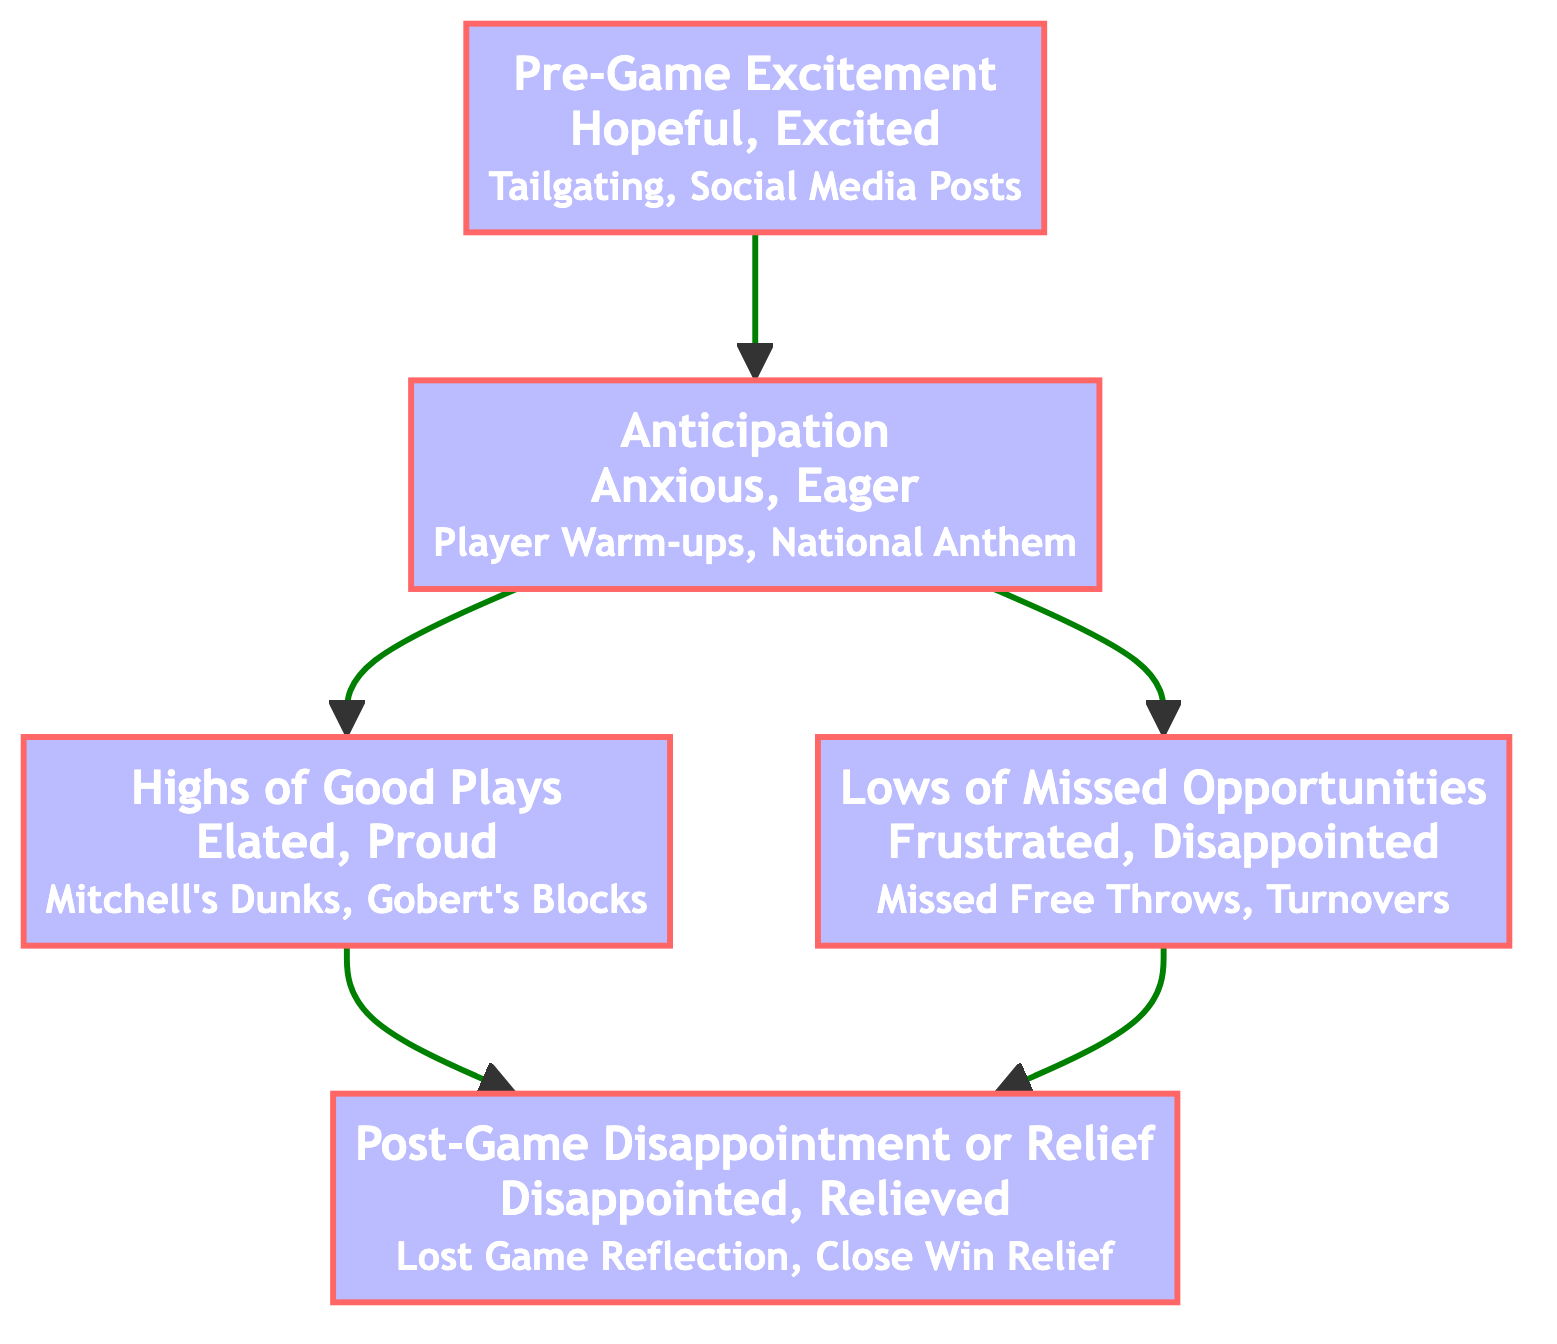What is the first emotion depicted in the flowchart? The flowchart starts with "Pre-Game Excitement," which is the bottom node.
Answer: Pre-Game Excitement How many nodes are there in the diagram? The diagram consists of five nodes, each representing different emotional states.
Answer: 5 What emotions are associated with "Highs of Good Plays"? The emotions linked to "Highs of Good Plays" are "elated" and "proud," as detailed in the node description.
Answer: Elated, Proud Which node connects directly to "Lows of Missed Opportunities"? "Anticipation" connects directly to "Lows of Missed Opportunities," as indicated by a direct flow from node 1 to node 3.
Answer: Anticipation What is the final emotional state after a game according to the flowchart? The ultimate emotional state depicted in the flowchart, at the top, is "Post-Game Disappointment or Relief."
Answer: Post-Game Disappointment or Relief If a game has many good plays, which emotion must be experienced before moving to the final post-game state? To reach "Post-Game Disappointment or Relief" after experiencing many good plays, one must first go through "Highs of Good Plays."
Answer: Highs of Good Plays What emotion is experienced during both "Anticipation" and "Lows of Missed Opportunities"? The emotions tied to "Anticipation" and "Lows of Missed Opportunities" include "anxious" and "frustrated," respectively, showing the contrasting feelings experienced. However, there is no emotion that overlaps in these two states.
Answer: None In what sequence do emotions flow from pre-game to post-game? The emotions flow from "Pre-Game Excitement" to "Anticipation," followed by either "Highs of Good Plays" or "Lows of Missed Opportunities," and culminates in "Post-Game Disappointment or Relief."
Answer: Pre-Game Excitement → Anticipation → (Highs of Good Plays or Lows of Missed Opportunities) → Post-Game Disappointment or Relief Identify the connection between "Highs of Good Plays" and "Post-Game Disappointment or Relief." "Highs of Good Plays" connects directly to "Post-Game Disappointment or Relief," indicating that positive experiences during the game can lead to different outcomes after the game.
Answer: Direct connection 